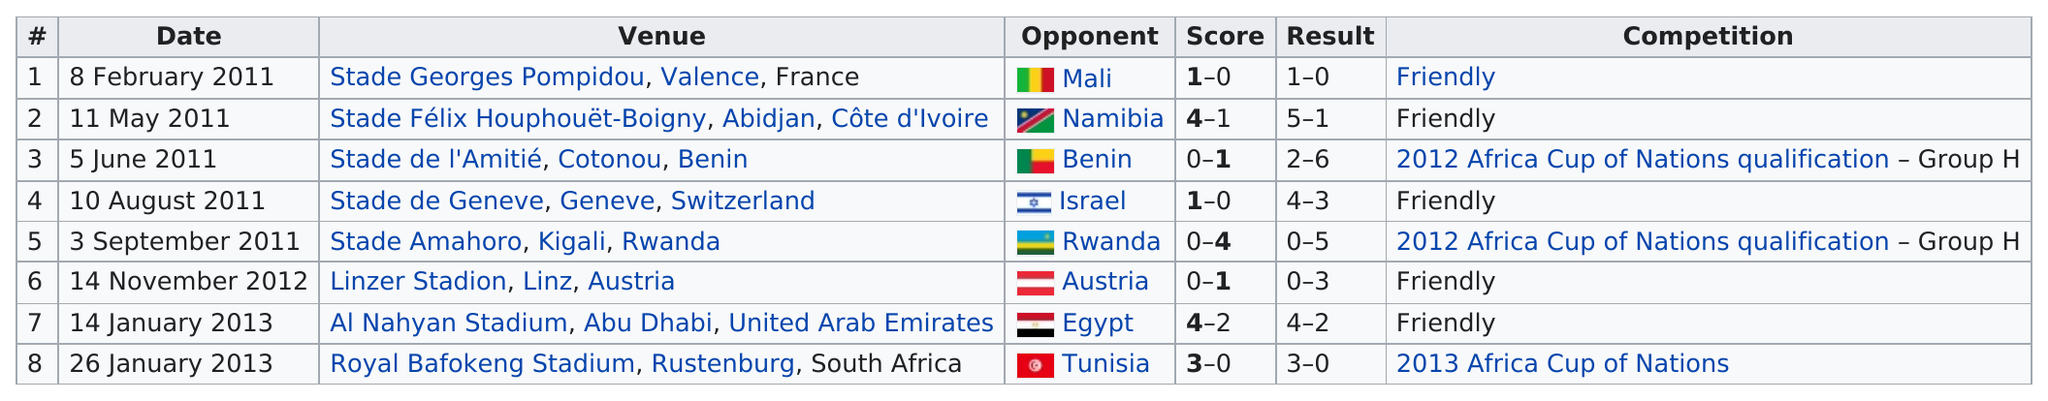Outline some significant characteristics in this image. On November 14th, 2012, the score was the same as the score in Benin. The 2013 Africa Cup of Nations took place after the game in Egypt, where the competition was held. In 2012, the total number of games played was 1. The last competition took place at the Royal Bafokeng Stadium in Rustenburg, South Africa. The opponent in the first game was Mali. 